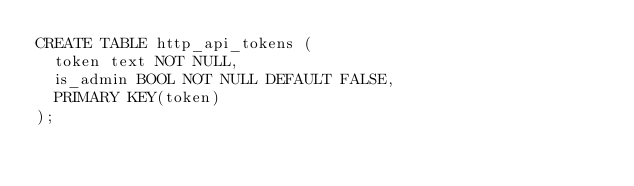Convert code to text. <code><loc_0><loc_0><loc_500><loc_500><_SQL_>CREATE TABLE http_api_tokens (
  token text NOT NULL,
  is_admin BOOL NOT NULL DEFAULT FALSE,
  PRIMARY KEY(token)
);</code> 